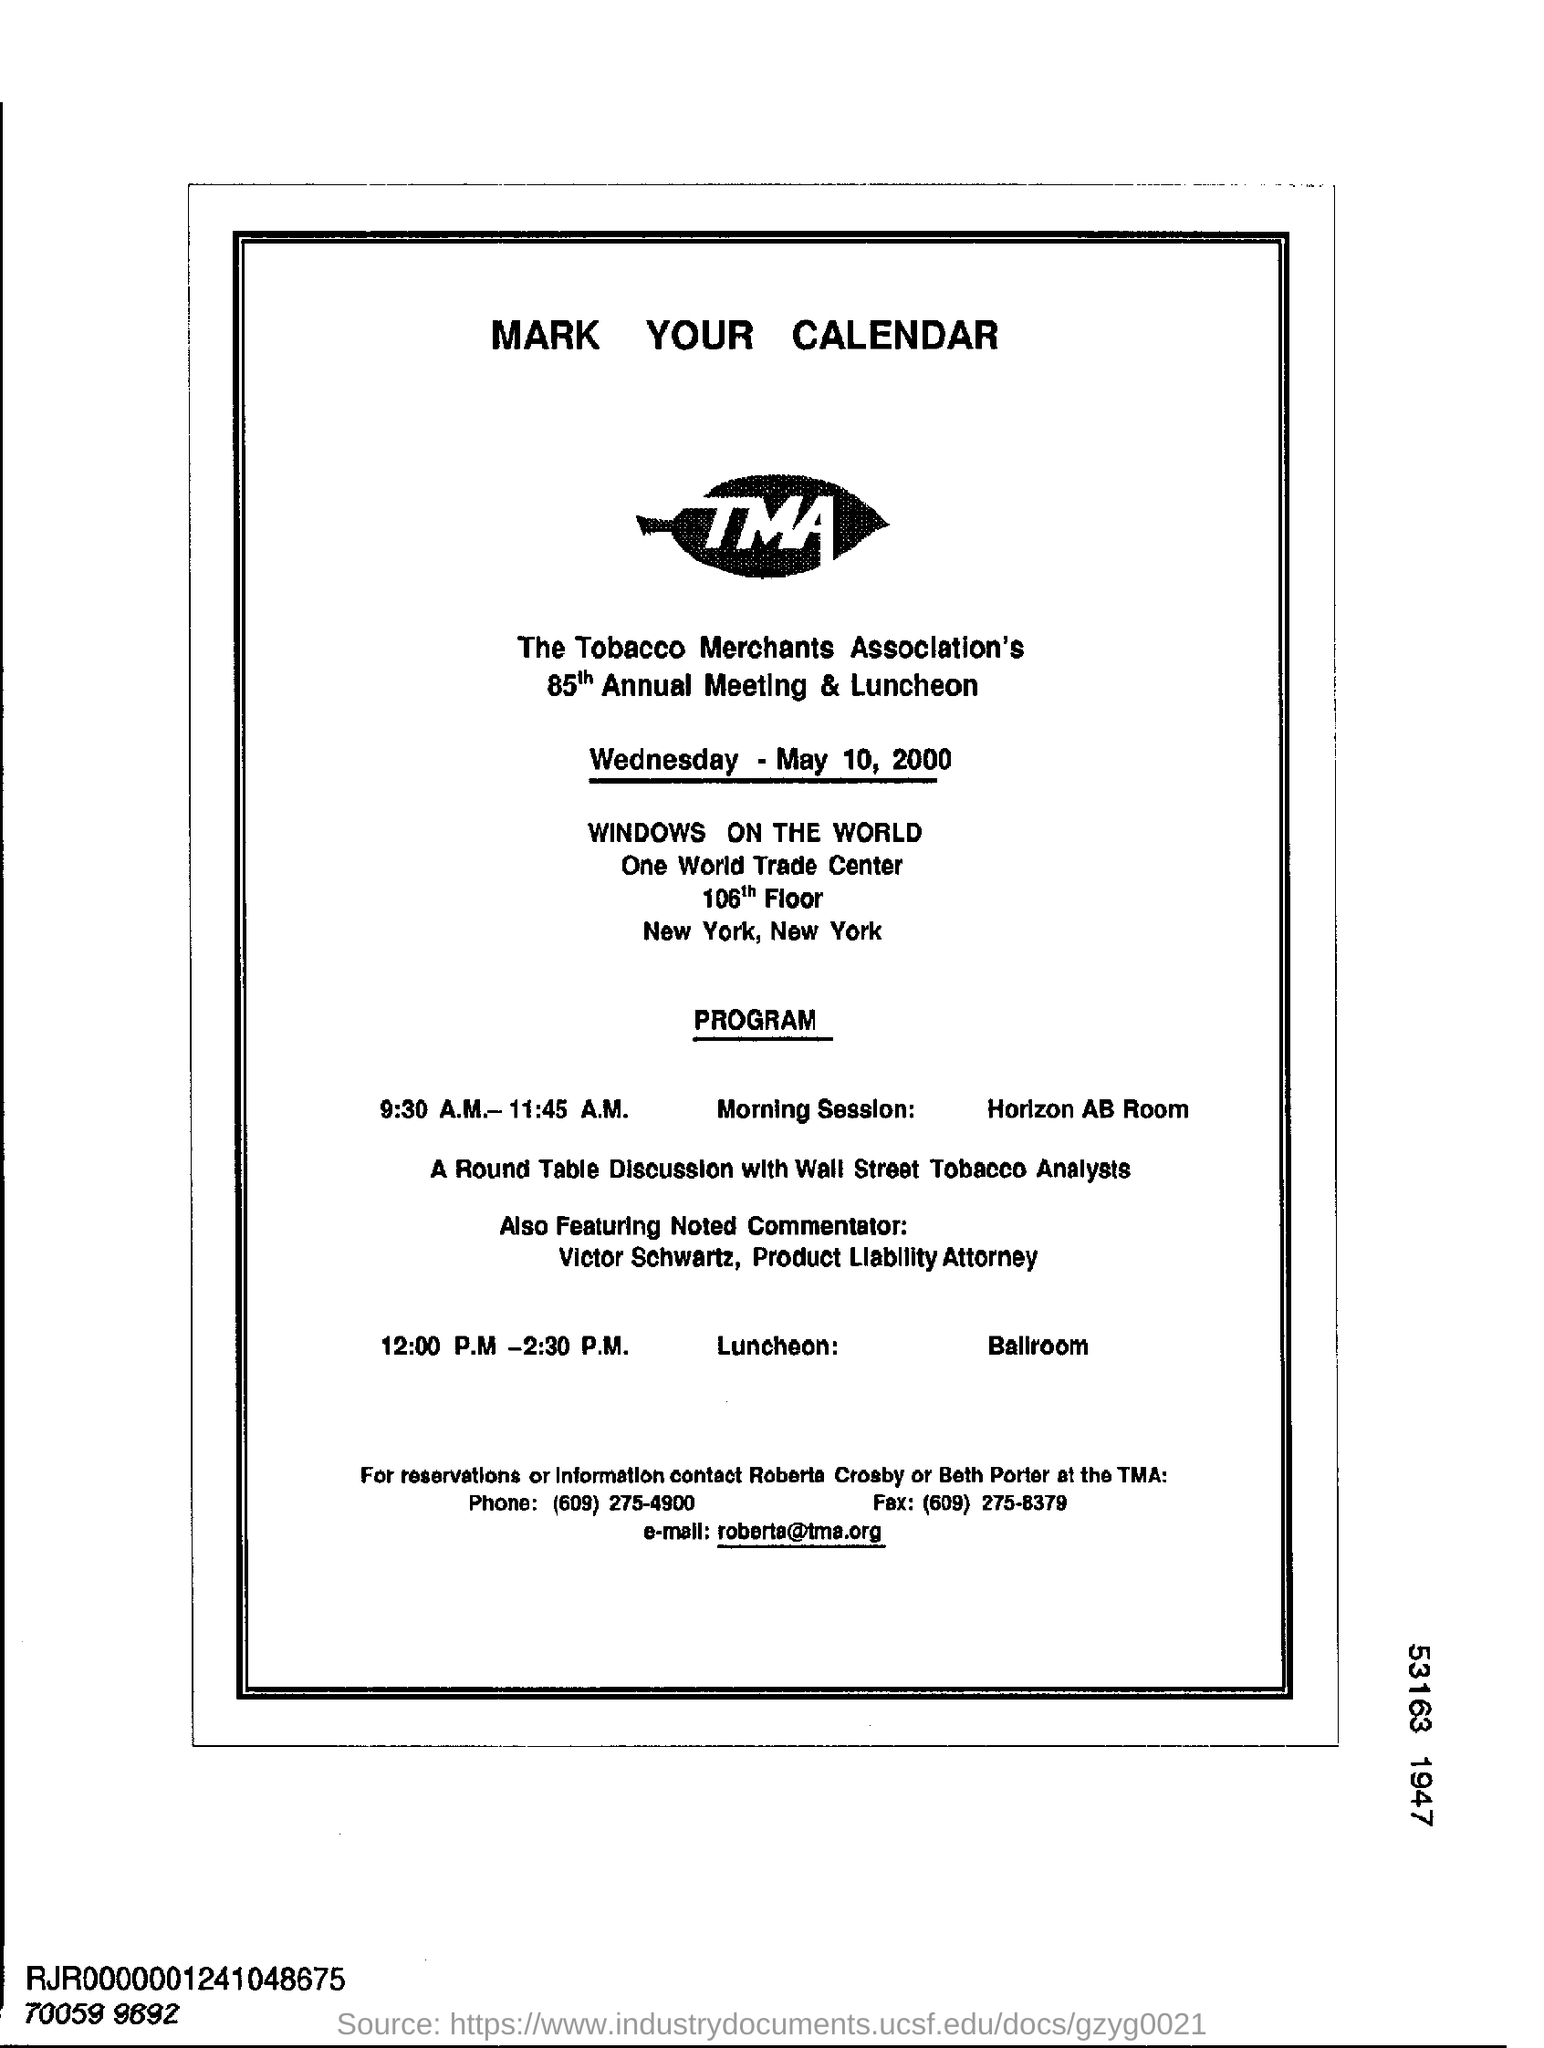Which association's 85th Annual meeting is mentioned here?
Provide a short and direct response. The tobacco merchants association' s. At what date, 85th Annual Meeting is scheduled?
Keep it short and to the point. May 10, 2000. What is the timing for morning session?
Provide a short and direct response. 9:30 A.M.- 11:45 A.M. For reservations or information what is the telephone number to contact?
Ensure brevity in your answer.  (609) 275 -4900. 